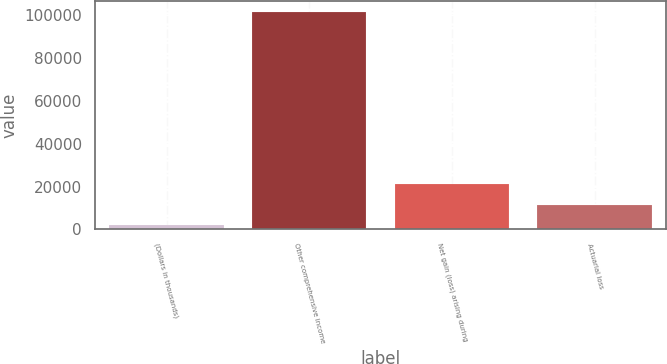Convert chart to OTSL. <chart><loc_0><loc_0><loc_500><loc_500><bar_chart><fcel>(Dollars in thousands)<fcel>Other comprehensive income<fcel>Net gain (loss) arising during<fcel>Actuarial loss<nl><fcel>2016<fcel>101415<fcel>21005.8<fcel>11510.9<nl></chart> 